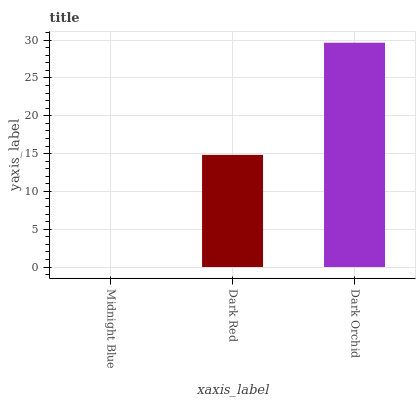Is Midnight Blue the minimum?
Answer yes or no. Yes. Is Dark Orchid the maximum?
Answer yes or no. Yes. Is Dark Red the minimum?
Answer yes or no. No. Is Dark Red the maximum?
Answer yes or no. No. Is Dark Red greater than Midnight Blue?
Answer yes or no. Yes. Is Midnight Blue less than Dark Red?
Answer yes or no. Yes. Is Midnight Blue greater than Dark Red?
Answer yes or no. No. Is Dark Red less than Midnight Blue?
Answer yes or no. No. Is Dark Red the high median?
Answer yes or no. Yes. Is Dark Red the low median?
Answer yes or no. Yes. Is Midnight Blue the high median?
Answer yes or no. No. Is Dark Orchid the low median?
Answer yes or no. No. 